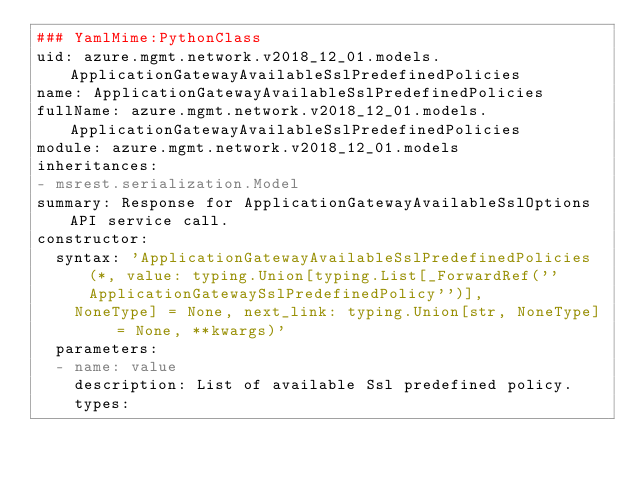<code> <loc_0><loc_0><loc_500><loc_500><_YAML_>### YamlMime:PythonClass
uid: azure.mgmt.network.v2018_12_01.models.ApplicationGatewayAvailableSslPredefinedPolicies
name: ApplicationGatewayAvailableSslPredefinedPolicies
fullName: azure.mgmt.network.v2018_12_01.models.ApplicationGatewayAvailableSslPredefinedPolicies
module: azure.mgmt.network.v2018_12_01.models
inheritances:
- msrest.serialization.Model
summary: Response for ApplicationGatewayAvailableSslOptions API service call.
constructor:
  syntax: 'ApplicationGatewayAvailableSslPredefinedPolicies(*, value: typing.Union[typing.List[_ForwardRef(''ApplicationGatewaySslPredefinedPolicy'')],
    NoneType] = None, next_link: typing.Union[str, NoneType] = None, **kwargs)'
  parameters:
  - name: value
    description: List of available Ssl predefined policy.
    types:</code> 